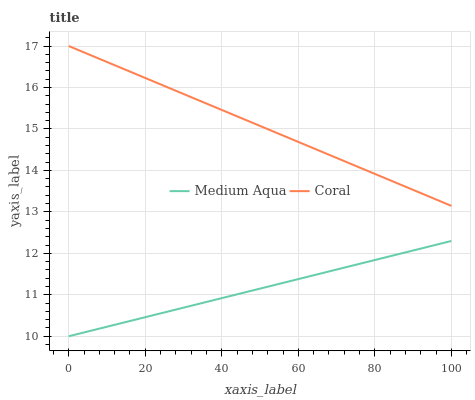Does Medium Aqua have the minimum area under the curve?
Answer yes or no. Yes. Does Coral have the maximum area under the curve?
Answer yes or no. Yes. Does Medium Aqua have the maximum area under the curve?
Answer yes or no. No. Is Medium Aqua the smoothest?
Answer yes or no. Yes. Is Coral the roughest?
Answer yes or no. Yes. Is Medium Aqua the roughest?
Answer yes or no. No. Does Medium Aqua have the lowest value?
Answer yes or no. Yes. Does Coral have the highest value?
Answer yes or no. Yes. Does Medium Aqua have the highest value?
Answer yes or no. No. Is Medium Aqua less than Coral?
Answer yes or no. Yes. Is Coral greater than Medium Aqua?
Answer yes or no. Yes. Does Medium Aqua intersect Coral?
Answer yes or no. No. 